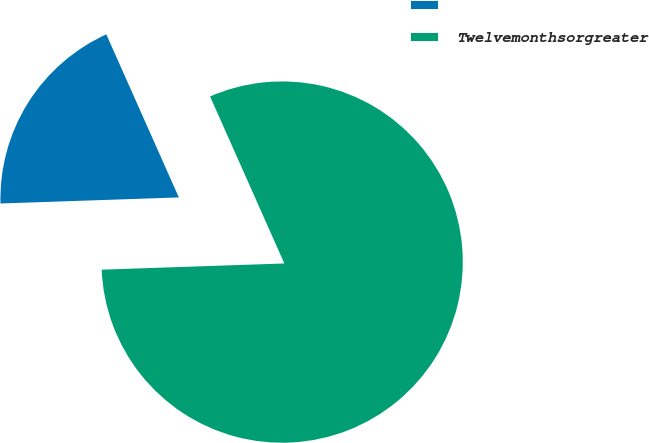Convert chart to OTSL. <chart><loc_0><loc_0><loc_500><loc_500><pie_chart><ecel><fcel>Twelvemonthsorgreater<nl><fcel>18.88%<fcel>81.12%<nl></chart> 